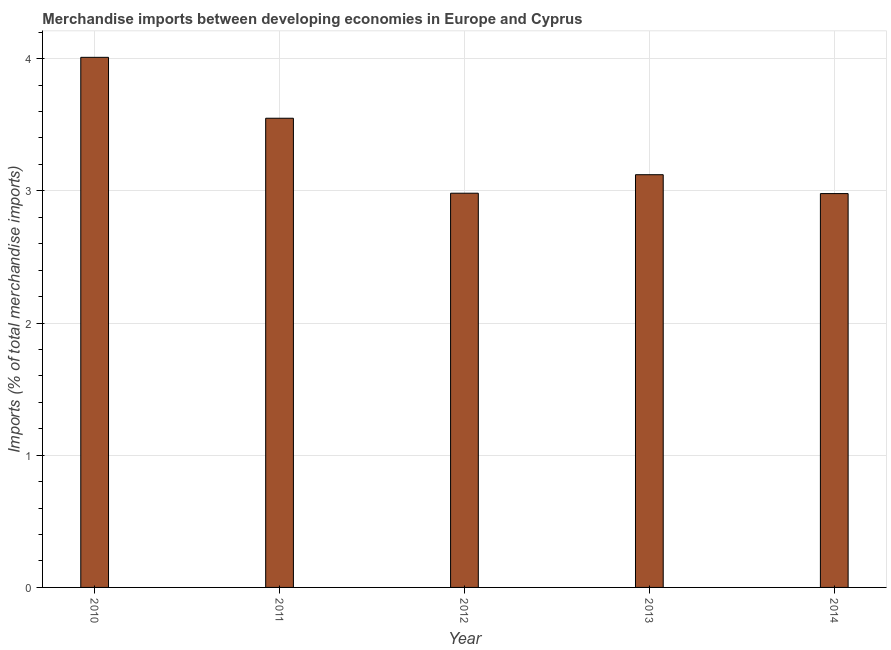What is the title of the graph?
Keep it short and to the point. Merchandise imports between developing economies in Europe and Cyprus. What is the label or title of the X-axis?
Offer a very short reply. Year. What is the label or title of the Y-axis?
Provide a succinct answer. Imports (% of total merchandise imports). What is the merchandise imports in 2011?
Provide a short and direct response. 3.55. Across all years, what is the maximum merchandise imports?
Ensure brevity in your answer.  4.01. Across all years, what is the minimum merchandise imports?
Provide a short and direct response. 2.98. In which year was the merchandise imports maximum?
Provide a short and direct response. 2010. What is the sum of the merchandise imports?
Keep it short and to the point. 16.64. What is the difference between the merchandise imports in 2010 and 2014?
Your answer should be very brief. 1.03. What is the average merchandise imports per year?
Give a very brief answer. 3.33. What is the median merchandise imports?
Keep it short and to the point. 3.12. In how many years, is the merchandise imports greater than 2 %?
Offer a terse response. 5. What is the ratio of the merchandise imports in 2010 to that in 2013?
Give a very brief answer. 1.28. Is the merchandise imports in 2011 less than that in 2013?
Offer a very short reply. No. Is the difference between the merchandise imports in 2010 and 2014 greater than the difference between any two years?
Your answer should be very brief. Yes. What is the difference between the highest and the second highest merchandise imports?
Ensure brevity in your answer.  0.46. In how many years, is the merchandise imports greater than the average merchandise imports taken over all years?
Offer a very short reply. 2. Are all the bars in the graph horizontal?
Your response must be concise. No. How many years are there in the graph?
Your response must be concise. 5. What is the difference between two consecutive major ticks on the Y-axis?
Offer a very short reply. 1. Are the values on the major ticks of Y-axis written in scientific E-notation?
Your response must be concise. No. What is the Imports (% of total merchandise imports) in 2010?
Make the answer very short. 4.01. What is the Imports (% of total merchandise imports) in 2011?
Offer a very short reply. 3.55. What is the Imports (% of total merchandise imports) in 2012?
Provide a short and direct response. 2.98. What is the Imports (% of total merchandise imports) of 2013?
Ensure brevity in your answer.  3.12. What is the Imports (% of total merchandise imports) of 2014?
Your answer should be compact. 2.98. What is the difference between the Imports (% of total merchandise imports) in 2010 and 2011?
Your answer should be very brief. 0.46. What is the difference between the Imports (% of total merchandise imports) in 2010 and 2012?
Your response must be concise. 1.03. What is the difference between the Imports (% of total merchandise imports) in 2010 and 2013?
Your response must be concise. 0.89. What is the difference between the Imports (% of total merchandise imports) in 2010 and 2014?
Your response must be concise. 1.03. What is the difference between the Imports (% of total merchandise imports) in 2011 and 2012?
Your response must be concise. 0.57. What is the difference between the Imports (% of total merchandise imports) in 2011 and 2013?
Give a very brief answer. 0.43. What is the difference between the Imports (% of total merchandise imports) in 2011 and 2014?
Offer a very short reply. 0.57. What is the difference between the Imports (% of total merchandise imports) in 2012 and 2013?
Your answer should be very brief. -0.14. What is the difference between the Imports (% of total merchandise imports) in 2012 and 2014?
Provide a short and direct response. 0. What is the difference between the Imports (% of total merchandise imports) in 2013 and 2014?
Provide a short and direct response. 0.14. What is the ratio of the Imports (% of total merchandise imports) in 2010 to that in 2011?
Your response must be concise. 1.13. What is the ratio of the Imports (% of total merchandise imports) in 2010 to that in 2012?
Provide a succinct answer. 1.34. What is the ratio of the Imports (% of total merchandise imports) in 2010 to that in 2013?
Your answer should be very brief. 1.28. What is the ratio of the Imports (% of total merchandise imports) in 2010 to that in 2014?
Provide a short and direct response. 1.35. What is the ratio of the Imports (% of total merchandise imports) in 2011 to that in 2012?
Your answer should be compact. 1.19. What is the ratio of the Imports (% of total merchandise imports) in 2011 to that in 2013?
Your answer should be very brief. 1.14. What is the ratio of the Imports (% of total merchandise imports) in 2011 to that in 2014?
Provide a short and direct response. 1.19. What is the ratio of the Imports (% of total merchandise imports) in 2012 to that in 2013?
Keep it short and to the point. 0.95. What is the ratio of the Imports (% of total merchandise imports) in 2013 to that in 2014?
Give a very brief answer. 1.05. 